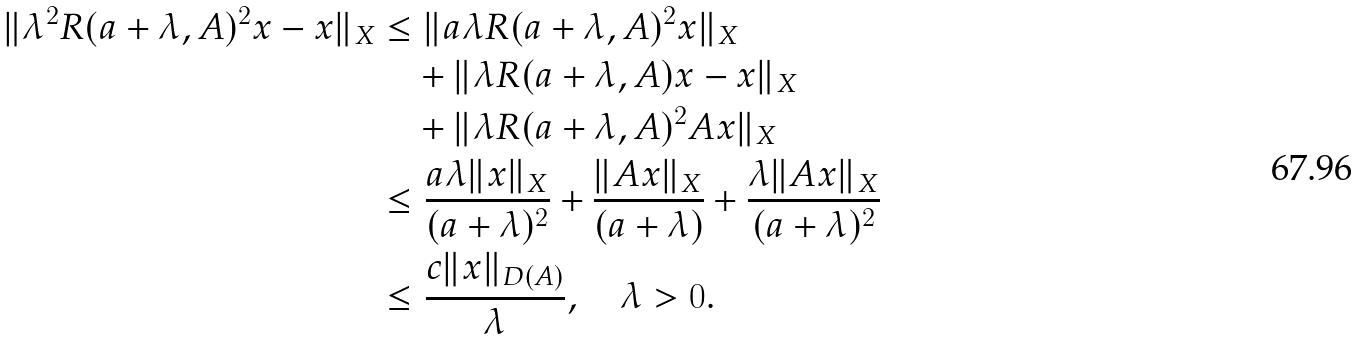<formula> <loc_0><loc_0><loc_500><loc_500>\| \lambda ^ { 2 } R ( a + \lambda , A ) ^ { 2 } x - x \| _ { X } & \leq \| a \lambda R ( a + \lambda , A ) ^ { 2 } x \| _ { X } \\ & \quad + \| \lambda R ( a + \lambda , A ) x - x \| _ { X } \\ & \quad + \| \lambda R ( a + \lambda , A ) ^ { 2 } A x \| _ { X } \\ & \leq \frac { a \lambda \| x \| _ { X } } { ( a + \lambda ) ^ { 2 } } + \frac { \| A x \| _ { X } } { ( a + \lambda ) } + \frac { \lambda \| A x \| _ { X } } { ( a + \lambda ) ^ { 2 } } \\ & \leq \frac { c \| x \| _ { D ( A ) } } { \lambda } , \quad \lambda > 0 .</formula> 